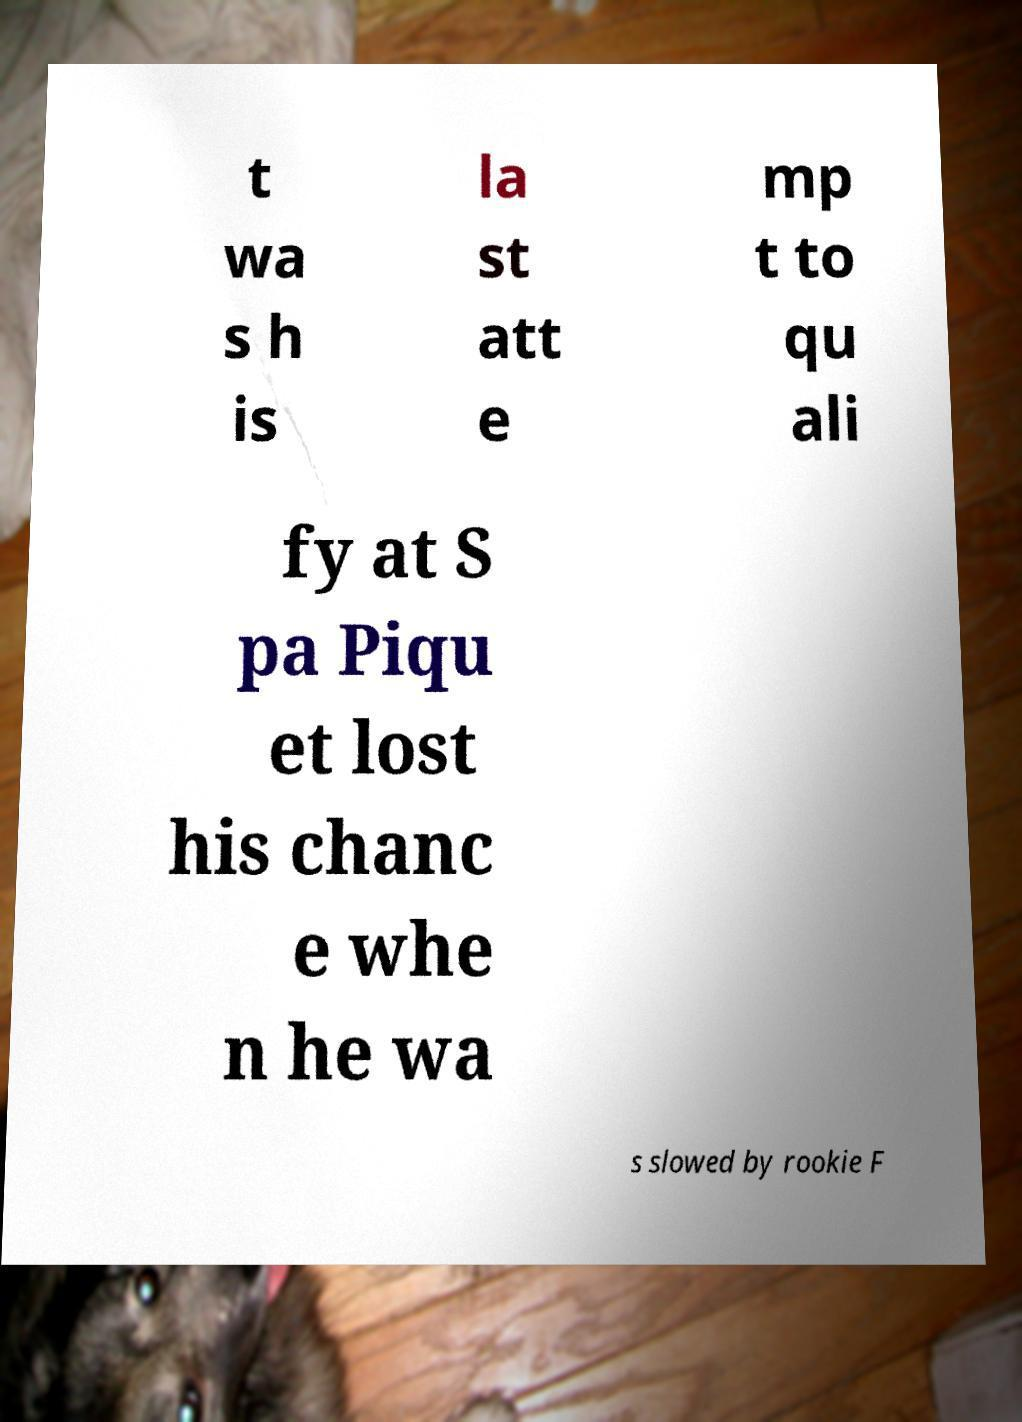There's text embedded in this image that I need extracted. Can you transcribe it verbatim? t wa s h is la st att e mp t to qu ali fy at S pa Piqu et lost his chanc e whe n he wa s slowed by rookie F 